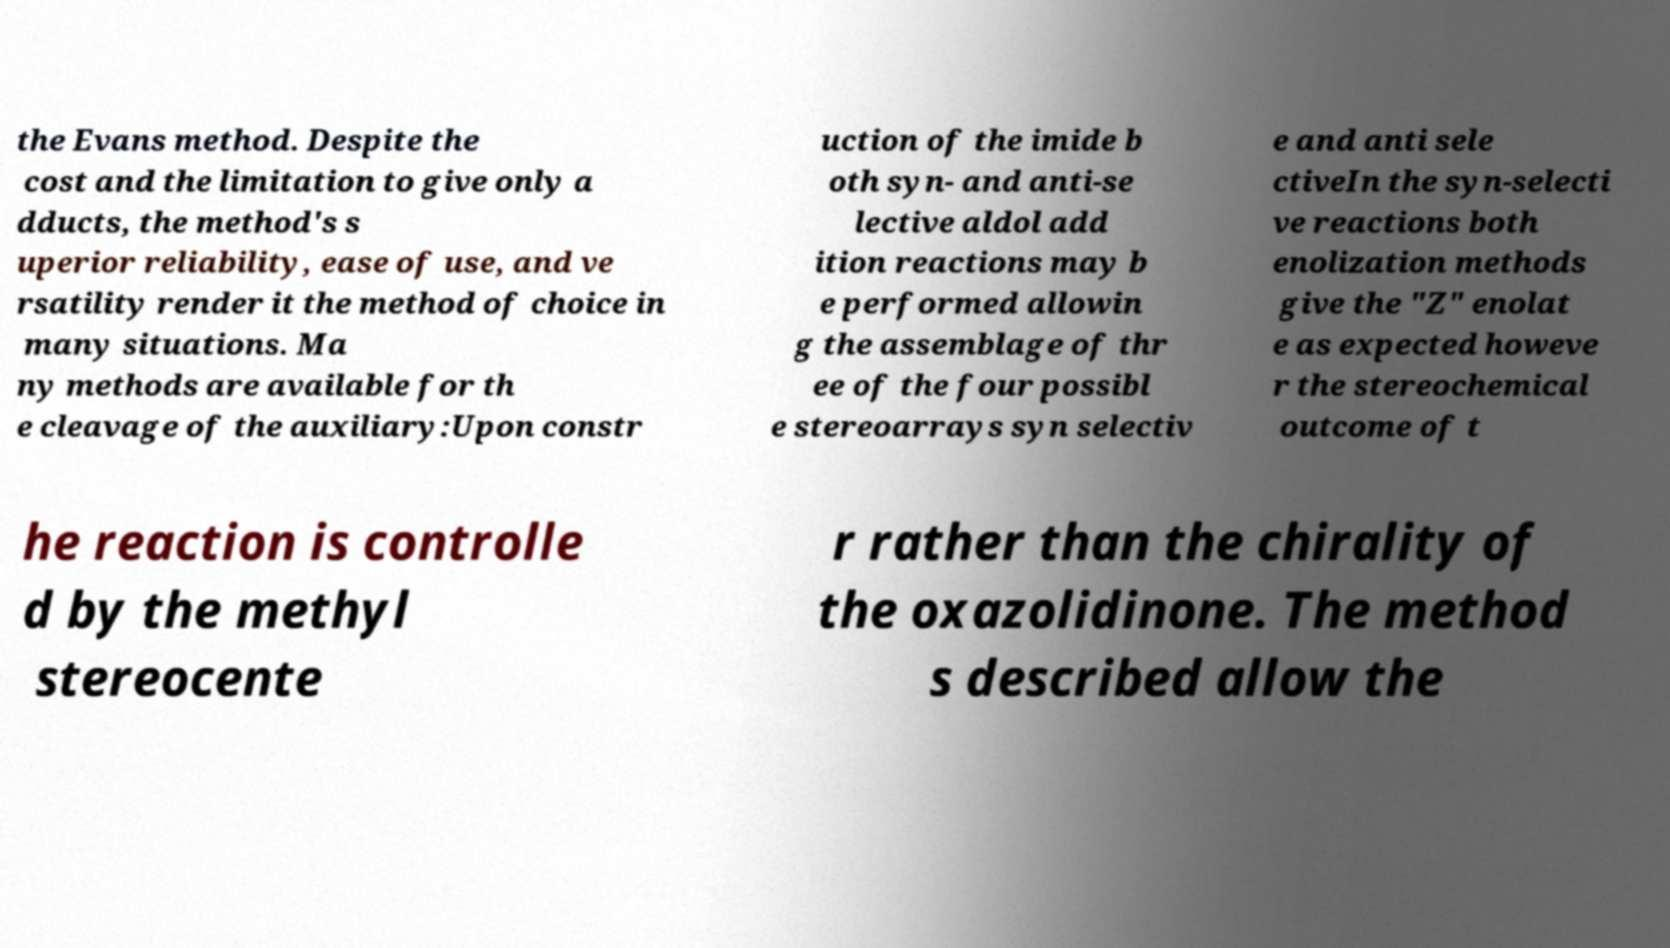I need the written content from this picture converted into text. Can you do that? the Evans method. Despite the cost and the limitation to give only a dducts, the method's s uperior reliability, ease of use, and ve rsatility render it the method of choice in many situations. Ma ny methods are available for th e cleavage of the auxiliary:Upon constr uction of the imide b oth syn- and anti-se lective aldol add ition reactions may b e performed allowin g the assemblage of thr ee of the four possibl e stereoarrays syn selectiv e and anti sele ctiveIn the syn-selecti ve reactions both enolization methods give the "Z" enolat e as expected howeve r the stereochemical outcome of t he reaction is controlle d by the methyl stereocente r rather than the chirality of the oxazolidinone. The method s described allow the 